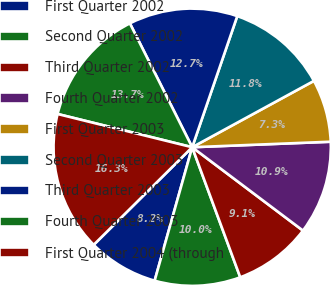Convert chart to OTSL. <chart><loc_0><loc_0><loc_500><loc_500><pie_chart><fcel>First Quarter 2002<fcel>Second Quarter 2002<fcel>Third Quarter 2002<fcel>Fourth Quarter 2002<fcel>First Quarter 2003<fcel>Second Quarter 2003<fcel>Third Quarter 2003<fcel>Fourth Quarter 2003<fcel>First Quarter 2004 (through<nl><fcel>8.21%<fcel>10.0%<fcel>9.1%<fcel>10.9%<fcel>7.31%<fcel>11.79%<fcel>12.69%<fcel>13.73%<fcel>16.28%<nl></chart> 